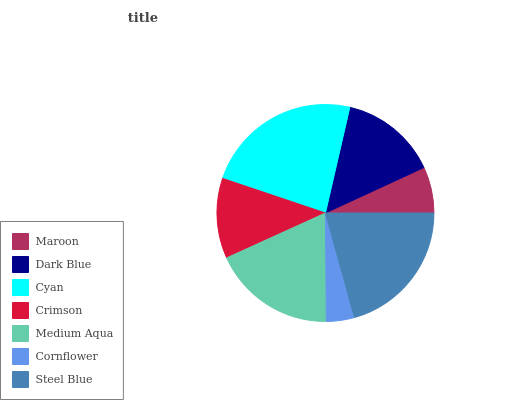Is Cornflower the minimum?
Answer yes or no. Yes. Is Cyan the maximum?
Answer yes or no. Yes. Is Dark Blue the minimum?
Answer yes or no. No. Is Dark Blue the maximum?
Answer yes or no. No. Is Dark Blue greater than Maroon?
Answer yes or no. Yes. Is Maroon less than Dark Blue?
Answer yes or no. Yes. Is Maroon greater than Dark Blue?
Answer yes or no. No. Is Dark Blue less than Maroon?
Answer yes or no. No. Is Dark Blue the high median?
Answer yes or no. Yes. Is Dark Blue the low median?
Answer yes or no. Yes. Is Crimson the high median?
Answer yes or no. No. Is Cornflower the low median?
Answer yes or no. No. 